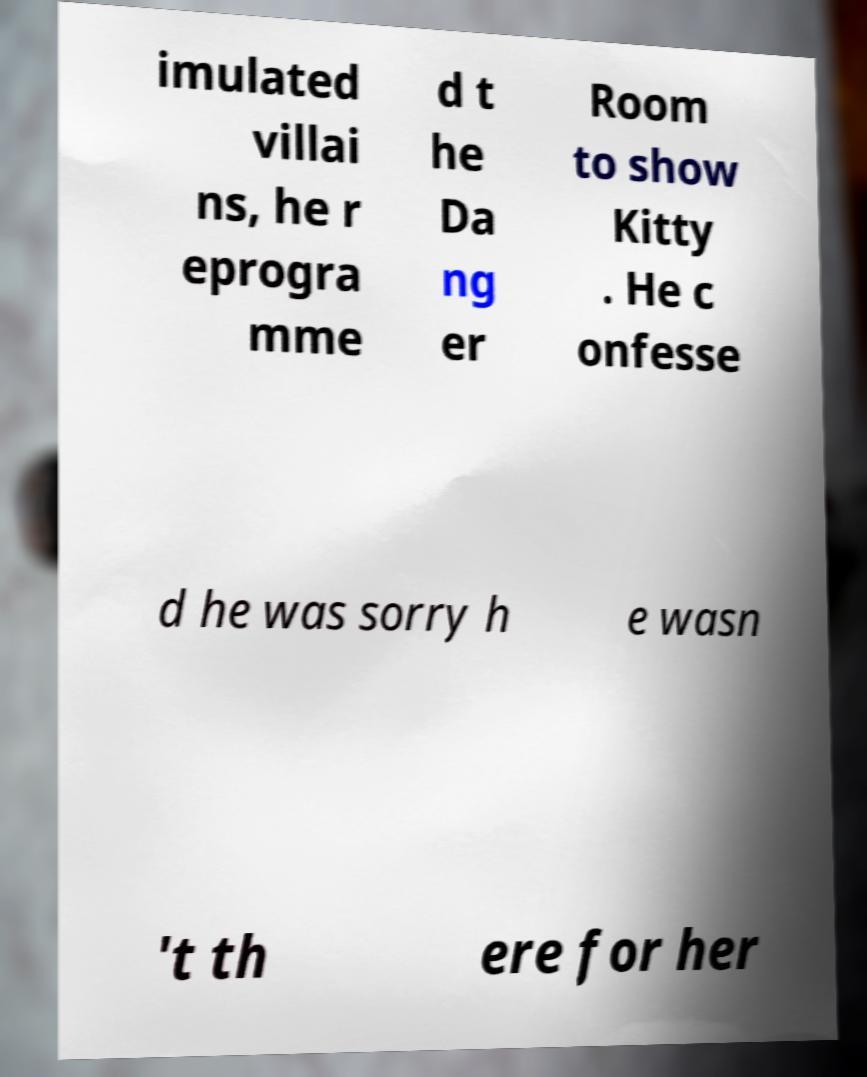For documentation purposes, I need the text within this image transcribed. Could you provide that? imulated villai ns, he r eprogra mme d t he Da ng er Room to show Kitty . He c onfesse d he was sorry h e wasn 't th ere for her 